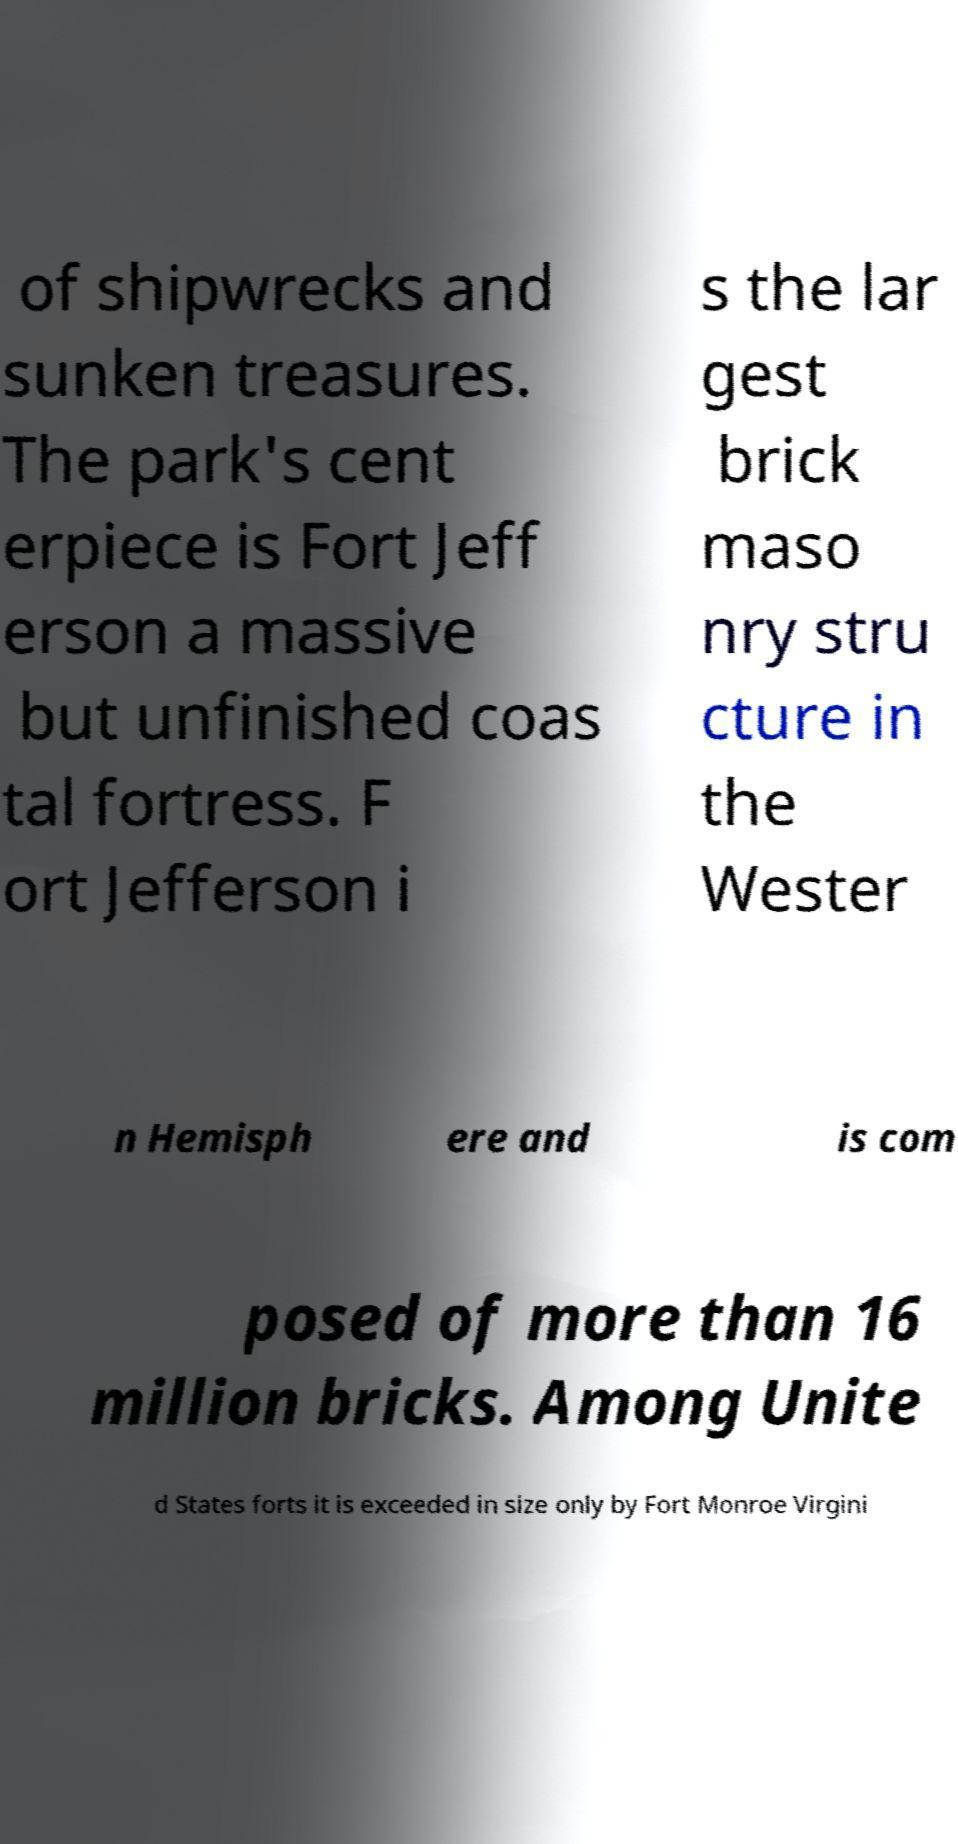I need the written content from this picture converted into text. Can you do that? of shipwrecks and sunken treasures. The park's cent erpiece is Fort Jeff erson a massive but unfinished coas tal fortress. F ort Jefferson i s the lar gest brick maso nry stru cture in the Wester n Hemisph ere and is com posed of more than 16 million bricks. Among Unite d States forts it is exceeded in size only by Fort Monroe Virgini 